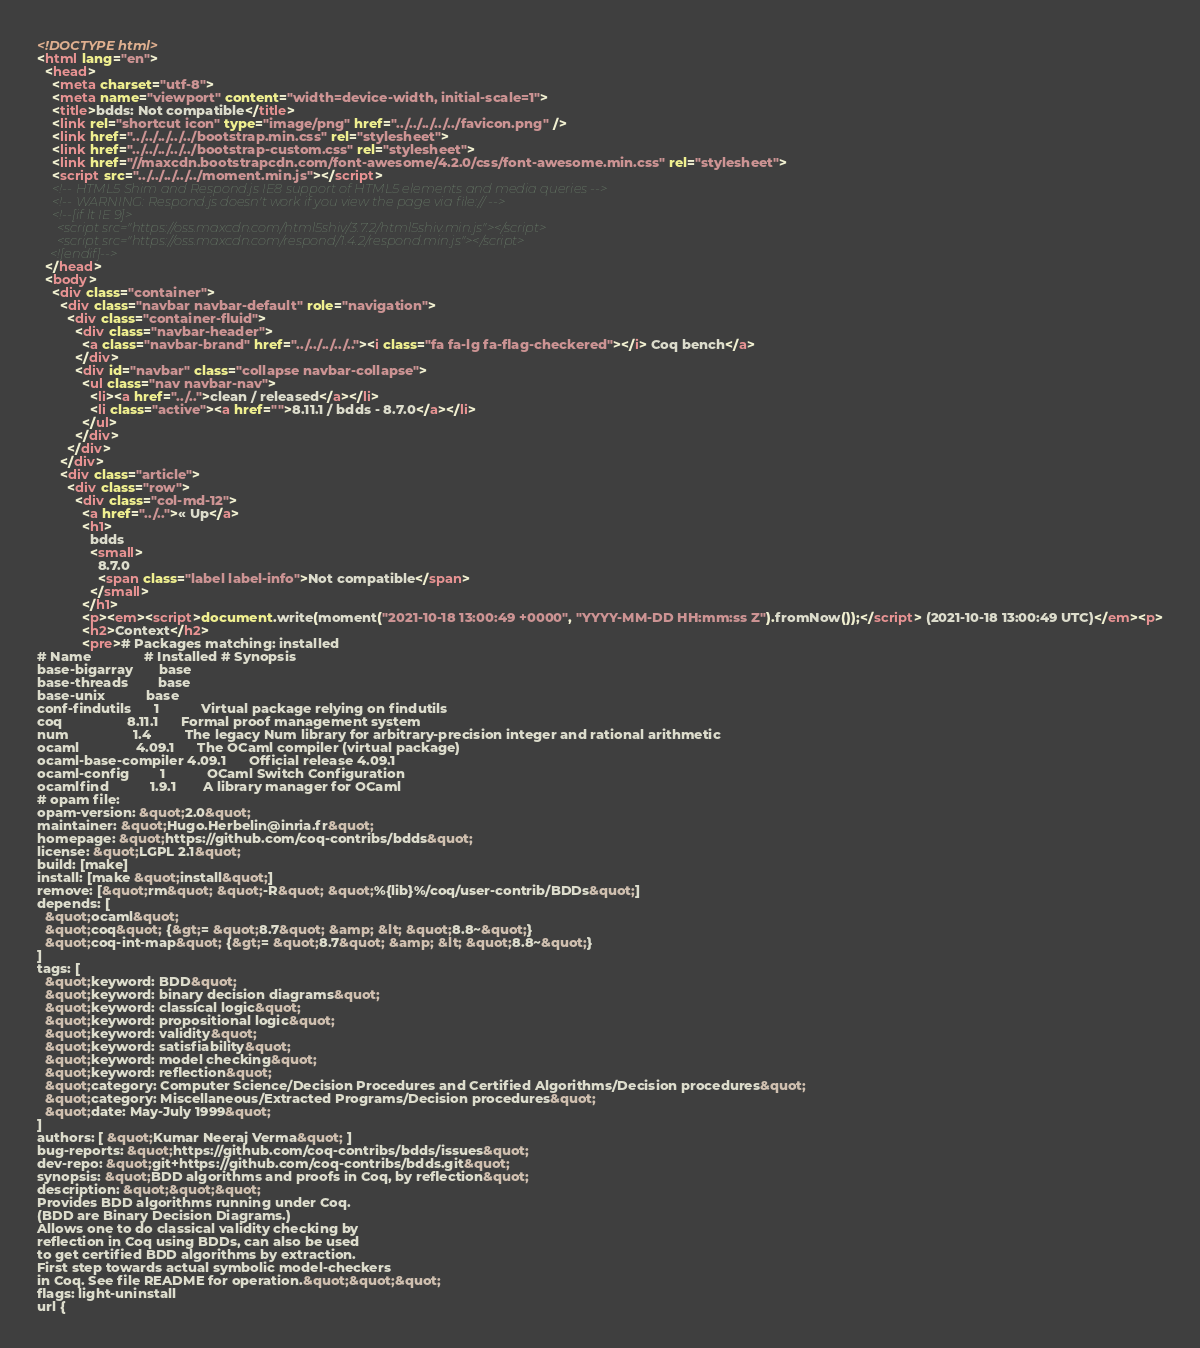<code> <loc_0><loc_0><loc_500><loc_500><_HTML_><!DOCTYPE html>
<html lang="en">
  <head>
    <meta charset="utf-8">
    <meta name="viewport" content="width=device-width, initial-scale=1">
    <title>bdds: Not compatible</title>
    <link rel="shortcut icon" type="image/png" href="../../../../../favicon.png" />
    <link href="../../../../../bootstrap.min.css" rel="stylesheet">
    <link href="../../../../../bootstrap-custom.css" rel="stylesheet">
    <link href="//maxcdn.bootstrapcdn.com/font-awesome/4.2.0/css/font-awesome.min.css" rel="stylesheet">
    <script src="../../../../../moment.min.js"></script>
    <!-- HTML5 Shim and Respond.js IE8 support of HTML5 elements and media queries -->
    <!-- WARNING: Respond.js doesn't work if you view the page via file:// -->
    <!--[if lt IE 9]>
      <script src="https://oss.maxcdn.com/html5shiv/3.7.2/html5shiv.min.js"></script>
      <script src="https://oss.maxcdn.com/respond/1.4.2/respond.min.js"></script>
    <![endif]-->
  </head>
  <body>
    <div class="container">
      <div class="navbar navbar-default" role="navigation">
        <div class="container-fluid">
          <div class="navbar-header">
            <a class="navbar-brand" href="../../../../.."><i class="fa fa-lg fa-flag-checkered"></i> Coq bench</a>
          </div>
          <div id="navbar" class="collapse navbar-collapse">
            <ul class="nav navbar-nav">
              <li><a href="../..">clean / released</a></li>
              <li class="active"><a href="">8.11.1 / bdds - 8.7.0</a></li>
            </ul>
          </div>
        </div>
      </div>
      <div class="article">
        <div class="row">
          <div class="col-md-12">
            <a href="../..">« Up</a>
            <h1>
              bdds
              <small>
                8.7.0
                <span class="label label-info">Not compatible</span>
              </small>
            </h1>
            <p><em><script>document.write(moment("2021-10-18 13:00:49 +0000", "YYYY-MM-DD HH:mm:ss Z").fromNow());</script> (2021-10-18 13:00:49 UTC)</em><p>
            <h2>Context</h2>
            <pre># Packages matching: installed
# Name              # Installed # Synopsis
base-bigarray       base
base-threads        base
base-unix           base
conf-findutils      1           Virtual package relying on findutils
coq                 8.11.1      Formal proof management system
num                 1.4         The legacy Num library for arbitrary-precision integer and rational arithmetic
ocaml               4.09.1      The OCaml compiler (virtual package)
ocaml-base-compiler 4.09.1      Official release 4.09.1
ocaml-config        1           OCaml Switch Configuration
ocamlfind           1.9.1       A library manager for OCaml
# opam file:
opam-version: &quot;2.0&quot;
maintainer: &quot;Hugo.Herbelin@inria.fr&quot;
homepage: &quot;https://github.com/coq-contribs/bdds&quot;
license: &quot;LGPL 2.1&quot;
build: [make]
install: [make &quot;install&quot;]
remove: [&quot;rm&quot; &quot;-R&quot; &quot;%{lib}%/coq/user-contrib/BDDs&quot;]
depends: [
  &quot;ocaml&quot;
  &quot;coq&quot; {&gt;= &quot;8.7&quot; &amp; &lt; &quot;8.8~&quot;}
  &quot;coq-int-map&quot; {&gt;= &quot;8.7&quot; &amp; &lt; &quot;8.8~&quot;}
]
tags: [
  &quot;keyword: BDD&quot;
  &quot;keyword: binary decision diagrams&quot;
  &quot;keyword: classical logic&quot;
  &quot;keyword: propositional logic&quot;
  &quot;keyword: validity&quot;
  &quot;keyword: satisfiability&quot;
  &quot;keyword: model checking&quot;
  &quot;keyword: reflection&quot;
  &quot;category: Computer Science/Decision Procedures and Certified Algorithms/Decision procedures&quot;
  &quot;category: Miscellaneous/Extracted Programs/Decision procedures&quot;
  &quot;date: May-July 1999&quot;
]
authors: [ &quot;Kumar Neeraj Verma&quot; ]
bug-reports: &quot;https://github.com/coq-contribs/bdds/issues&quot;
dev-repo: &quot;git+https://github.com/coq-contribs/bdds.git&quot;
synopsis: &quot;BDD algorithms and proofs in Coq, by reflection&quot;
description: &quot;&quot;&quot;
Provides BDD algorithms running under Coq.
(BDD are Binary Decision Diagrams.)
Allows one to do classical validity checking by
reflection in Coq using BDDs, can also be used
to get certified BDD algorithms by extraction.
First step towards actual symbolic model-checkers
in Coq. See file README for operation.&quot;&quot;&quot;
flags: light-uninstall
url {</code> 